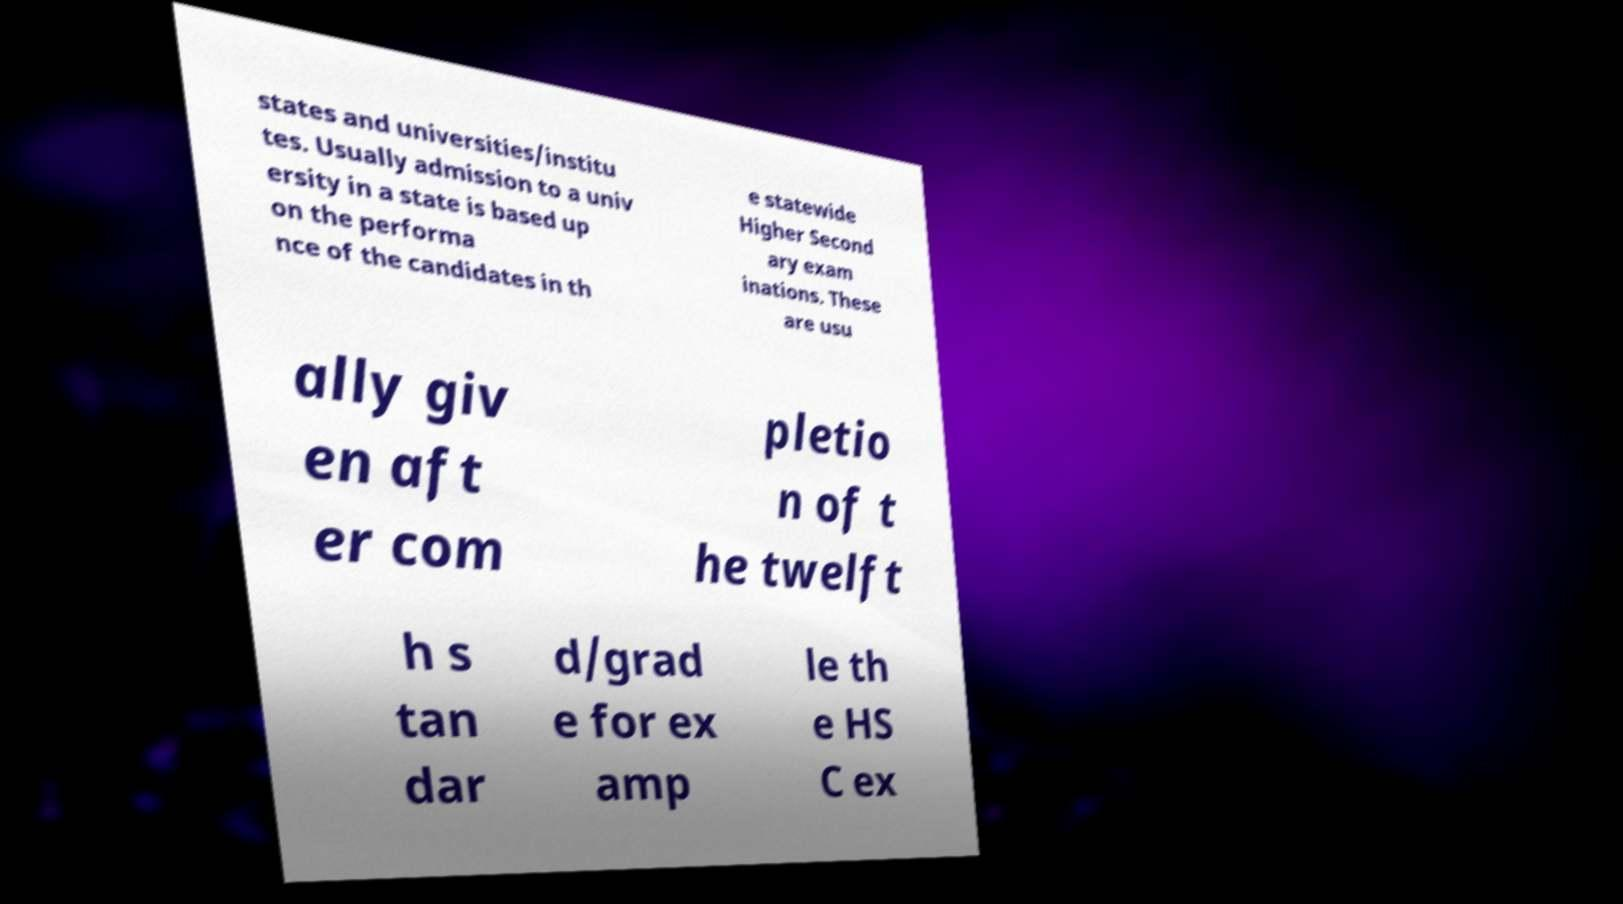Can you accurately transcribe the text from the provided image for me? states and universities/institu tes. Usually admission to a univ ersity in a state is based up on the performa nce of the candidates in th e statewide Higher Second ary exam inations. These are usu ally giv en aft er com pletio n of t he twelft h s tan dar d/grad e for ex amp le th e HS C ex 